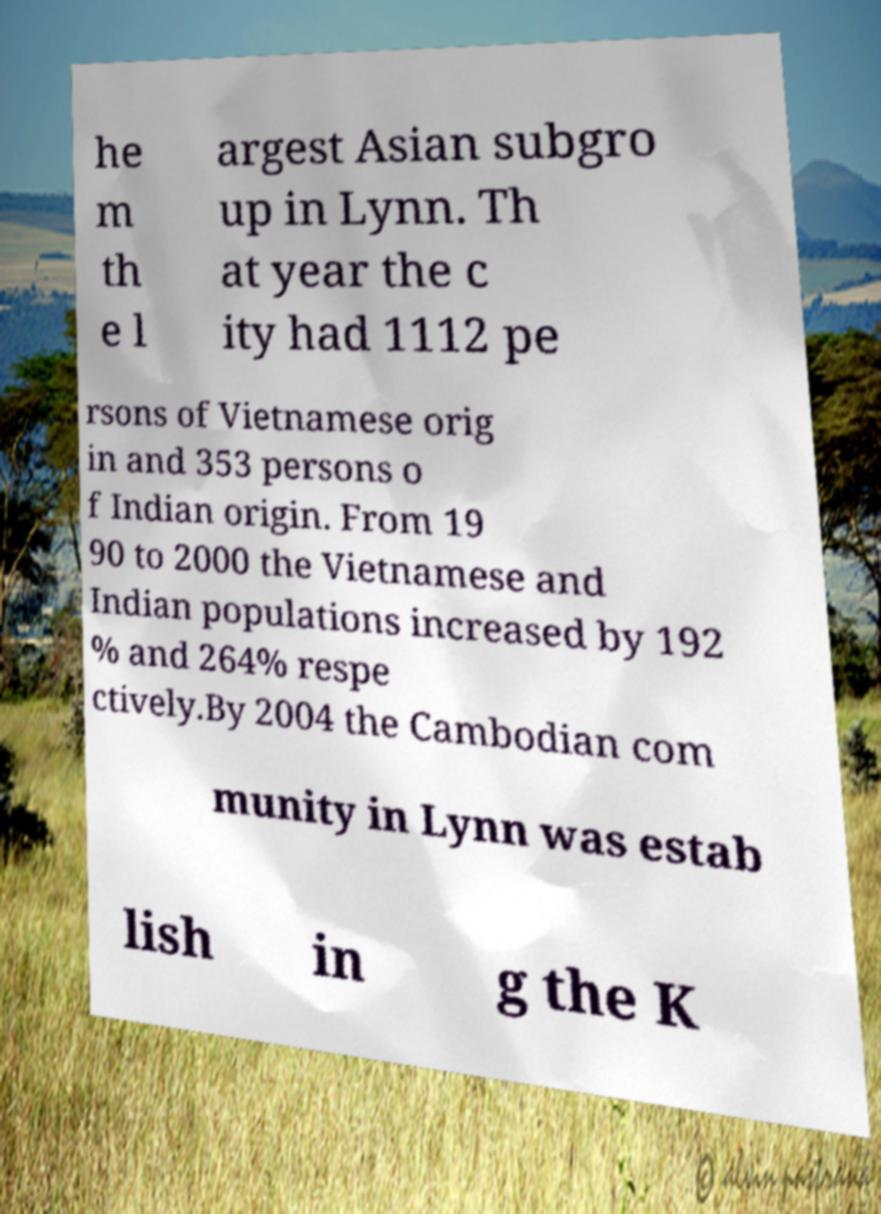Can you read and provide the text displayed in the image?This photo seems to have some interesting text. Can you extract and type it out for me? he m th e l argest Asian subgro up in Lynn. Th at year the c ity had 1112 pe rsons of Vietnamese orig in and 353 persons o f Indian origin. From 19 90 to 2000 the Vietnamese and Indian populations increased by 192 % and 264% respe ctively.By 2004 the Cambodian com munity in Lynn was estab lish in g the K 